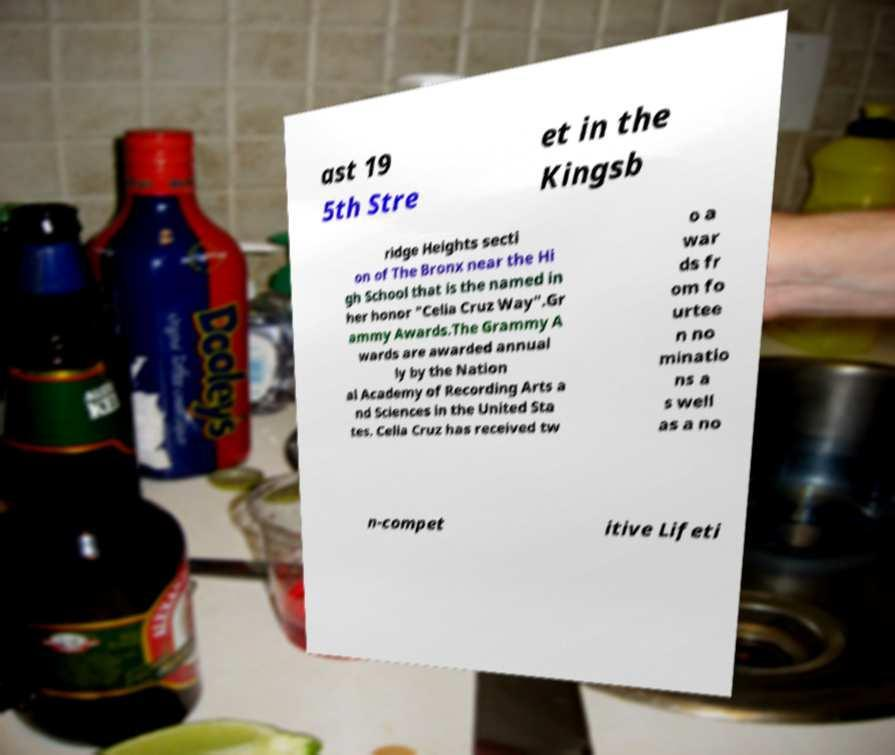I need the written content from this picture converted into text. Can you do that? ast 19 5th Stre et in the Kingsb ridge Heights secti on of The Bronx near the Hi gh School that is the named in her honor "Celia Cruz Way".Gr ammy Awards.The Grammy A wards are awarded annual ly by the Nation al Academy of Recording Arts a nd Sciences in the United Sta tes. Celia Cruz has received tw o a war ds fr om fo urtee n no minatio ns a s well as a no n-compet itive Lifeti 